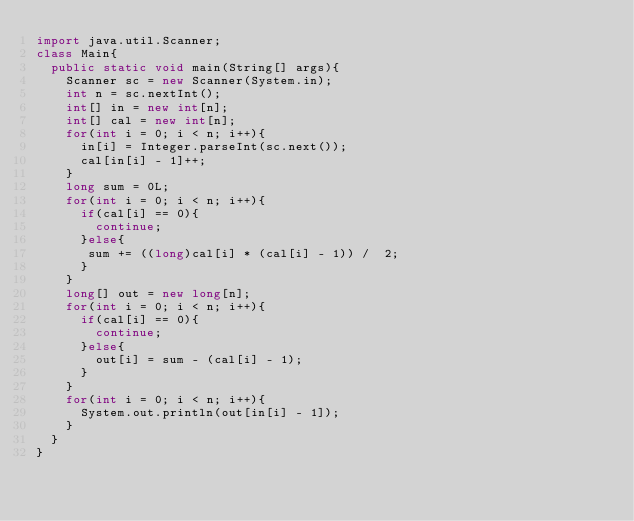<code> <loc_0><loc_0><loc_500><loc_500><_Java_>import java.util.Scanner;
class Main{
  public static void main(String[] args){
    Scanner sc = new Scanner(System.in);
    int n = sc.nextInt();
    int[] in = new int[n];
    int[] cal = new int[n];
    for(int i = 0; i < n; i++){
      in[i] = Integer.parseInt(sc.next());
      cal[in[i] - 1]++;
    }
    long sum = 0L;
    for(int i = 0; i < n; i++){
      if(cal[i] == 0){
        continue;
      }else{
       sum += ((long)cal[i] * (cal[i] - 1)) /  2;
      }
    }
    long[] out = new long[n];
    for(int i = 0; i < n; i++){
      if(cal[i] == 0){
        continue;
      }else{
        out[i] = sum - (cal[i] - 1);
      }
    }
    for(int i = 0; i < n; i++){
      System.out.println(out[in[i] - 1]);
    }
  }
}</code> 